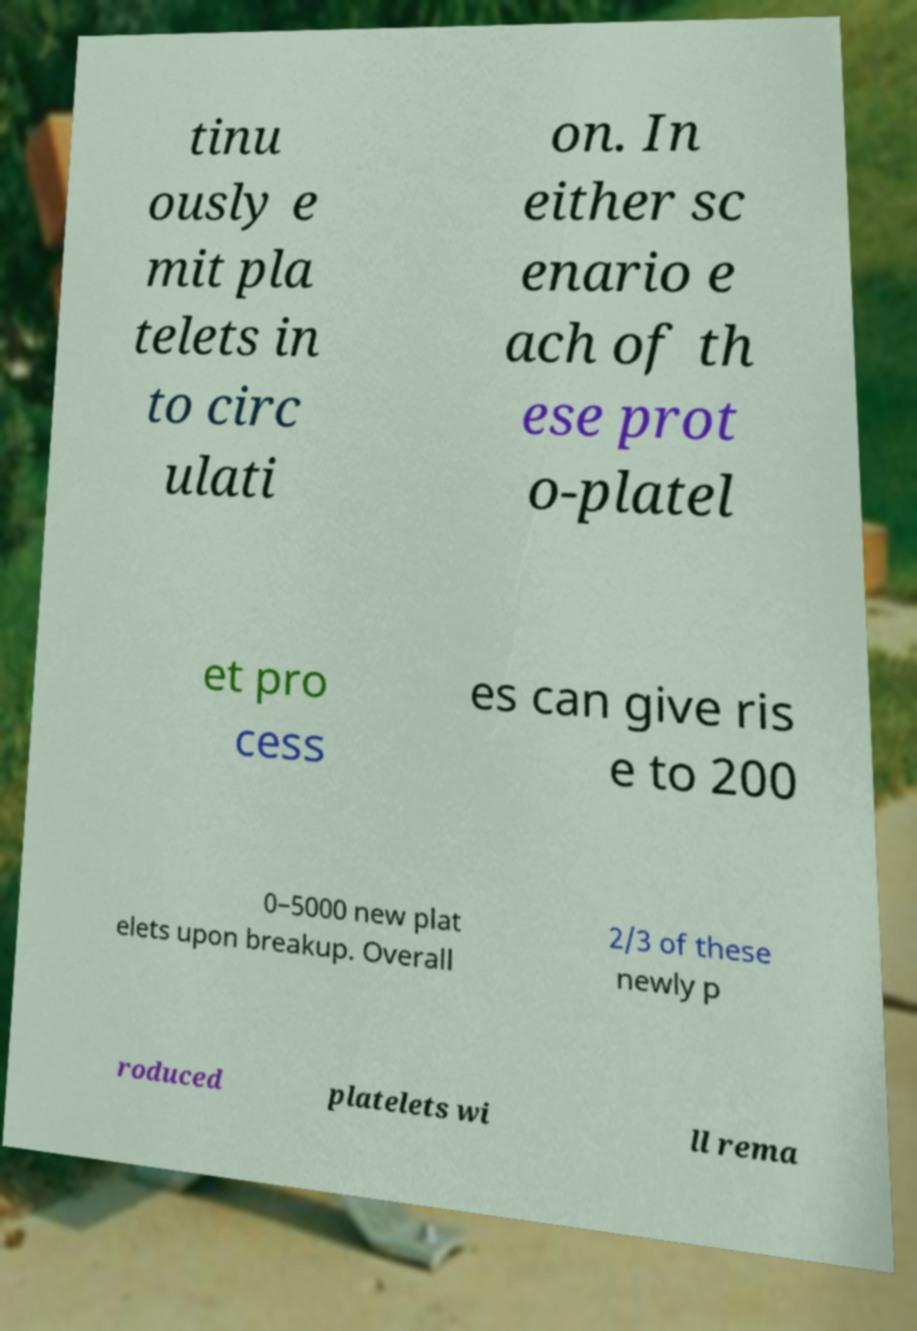Please read and relay the text visible in this image. What does it say? tinu ously e mit pla telets in to circ ulati on. In either sc enario e ach of th ese prot o-platel et pro cess es can give ris e to 200 0–5000 new plat elets upon breakup. Overall 2/3 of these newly p roduced platelets wi ll rema 